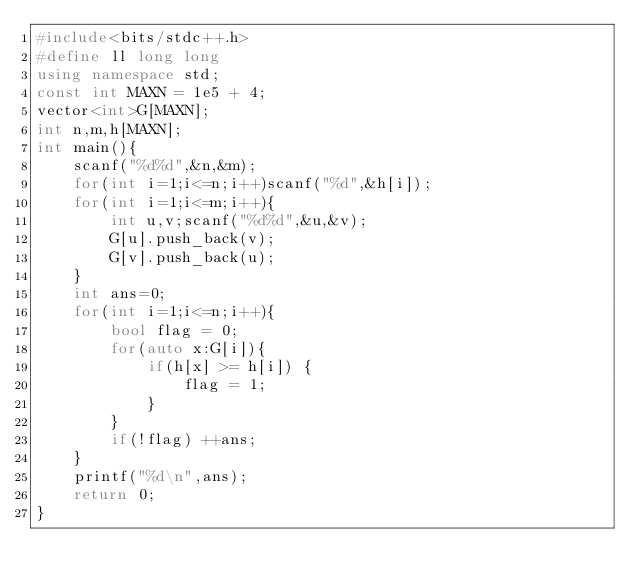<code> <loc_0><loc_0><loc_500><loc_500><_C++_>#include<bits/stdc++.h>
#define ll long long
using namespace std;
const int MAXN = 1e5 + 4;
vector<int>G[MAXN];
int n,m,h[MAXN];
int main(){
    scanf("%d%d",&n,&m);
    for(int i=1;i<=n;i++)scanf("%d",&h[i]);
    for(int i=1;i<=m;i++){
        int u,v;scanf("%d%d",&u,&v);
        G[u].push_back(v);
        G[v].push_back(u);
    }
    int ans=0;
    for(int i=1;i<=n;i++){
        bool flag = 0;
        for(auto x:G[i]){
            if(h[x] >= h[i]) {
                flag = 1;
            }
        }
        if(!flag) ++ans;
    }
    printf("%d\n",ans);
    return 0;
}
</code> 